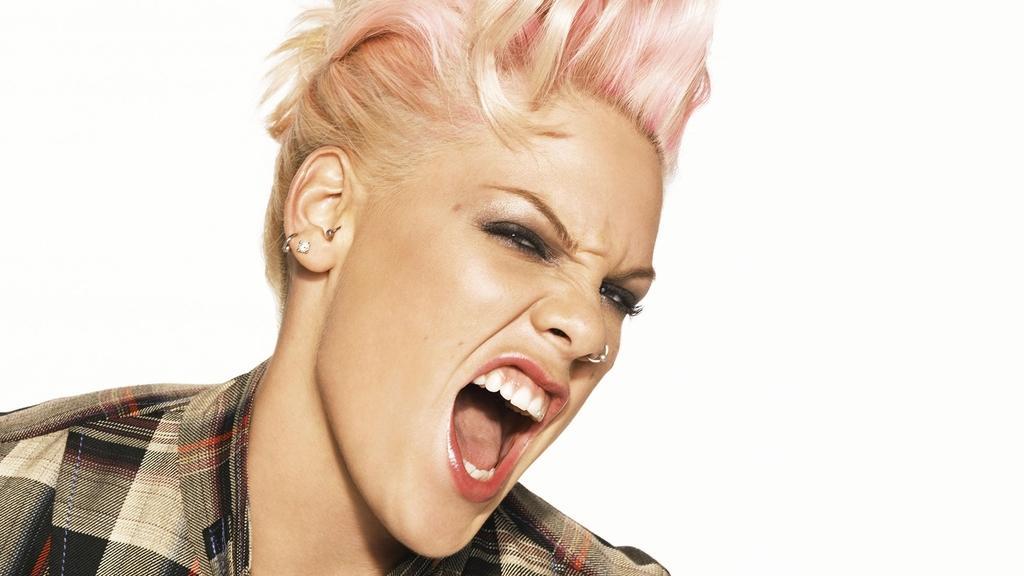In one or two sentences, can you explain what this image depicts? In this picture there is a woman who is wearing shirt, nose ring and earring. In the back I can see the brightness. 